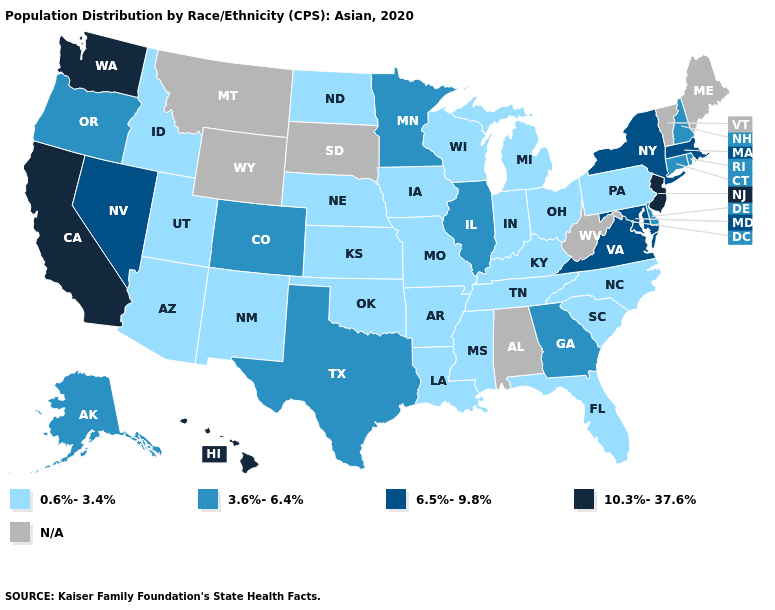What is the highest value in the USA?
Give a very brief answer. 10.3%-37.6%. What is the value of Montana?
Write a very short answer. N/A. Name the states that have a value in the range 10.3%-37.6%?
Quick response, please. California, Hawaii, New Jersey, Washington. Does the map have missing data?
Answer briefly. Yes. Name the states that have a value in the range 6.5%-9.8%?
Give a very brief answer. Maryland, Massachusetts, Nevada, New York, Virginia. Name the states that have a value in the range N/A?
Concise answer only. Alabama, Maine, Montana, South Dakota, Vermont, West Virginia, Wyoming. Which states have the highest value in the USA?
Quick response, please. California, Hawaii, New Jersey, Washington. What is the value of Oklahoma?
Keep it brief. 0.6%-3.4%. Which states have the lowest value in the Northeast?
Keep it brief. Pennsylvania. Name the states that have a value in the range 6.5%-9.8%?
Concise answer only. Maryland, Massachusetts, Nevada, New York, Virginia. What is the highest value in the Northeast ?
Short answer required. 10.3%-37.6%. Name the states that have a value in the range 6.5%-9.8%?
Short answer required. Maryland, Massachusetts, Nevada, New York, Virginia. Name the states that have a value in the range N/A?
Answer briefly. Alabama, Maine, Montana, South Dakota, Vermont, West Virginia, Wyoming. What is the value of South Dakota?
Write a very short answer. N/A. 